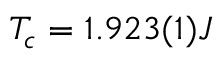Convert formula to latex. <formula><loc_0><loc_0><loc_500><loc_500>T _ { c } = 1 . 9 2 3 ( 1 ) J</formula> 